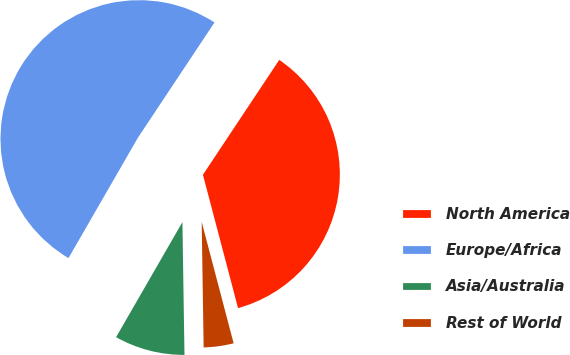Convert chart to OTSL. <chart><loc_0><loc_0><loc_500><loc_500><pie_chart><fcel>North America<fcel>Europe/Africa<fcel>Asia/Australia<fcel>Rest of World<nl><fcel>36.57%<fcel>51.01%<fcel>8.57%<fcel>3.85%<nl></chart> 